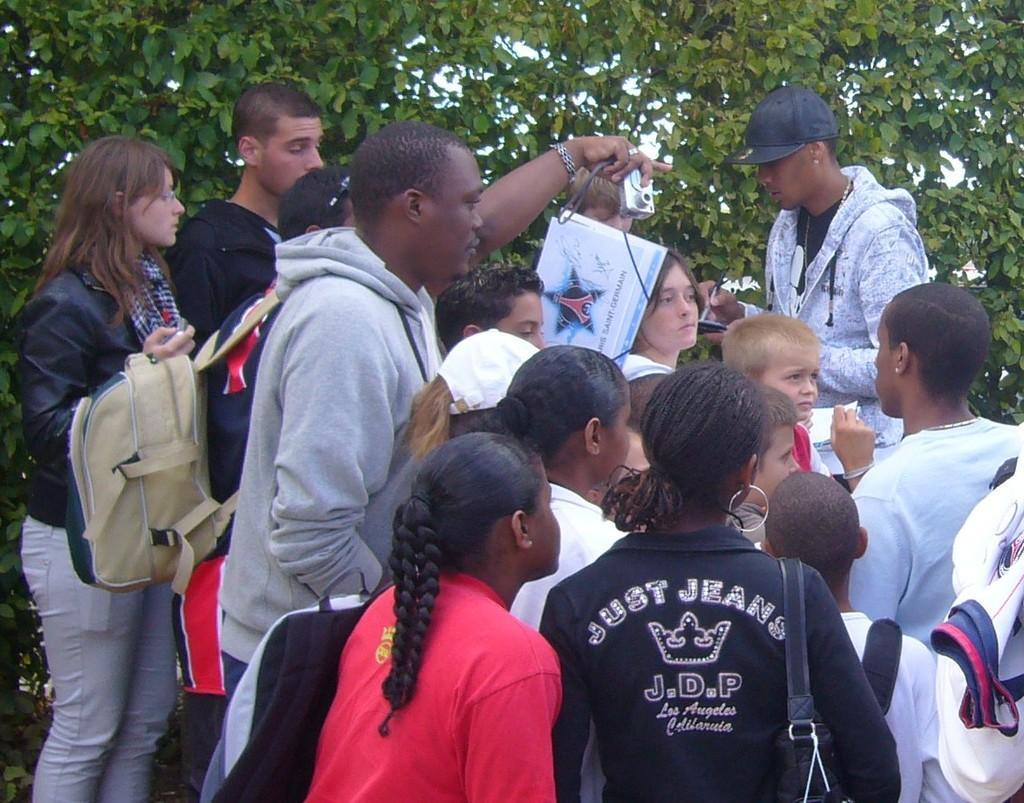Could you give a brief overview of what you see in this image? In this image I can see group of persons visible and they are holding bags and papers and camera and at the top I can see trees. 